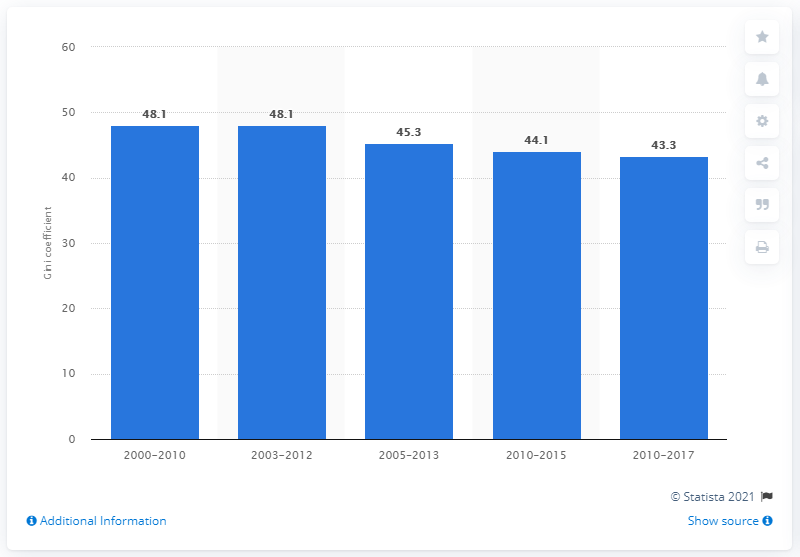Indicate a few pertinent items in this graphic. The Gini coefficient in Peru in 2017 was 43.3, which indicates a moderate level of income inequality in the country. 